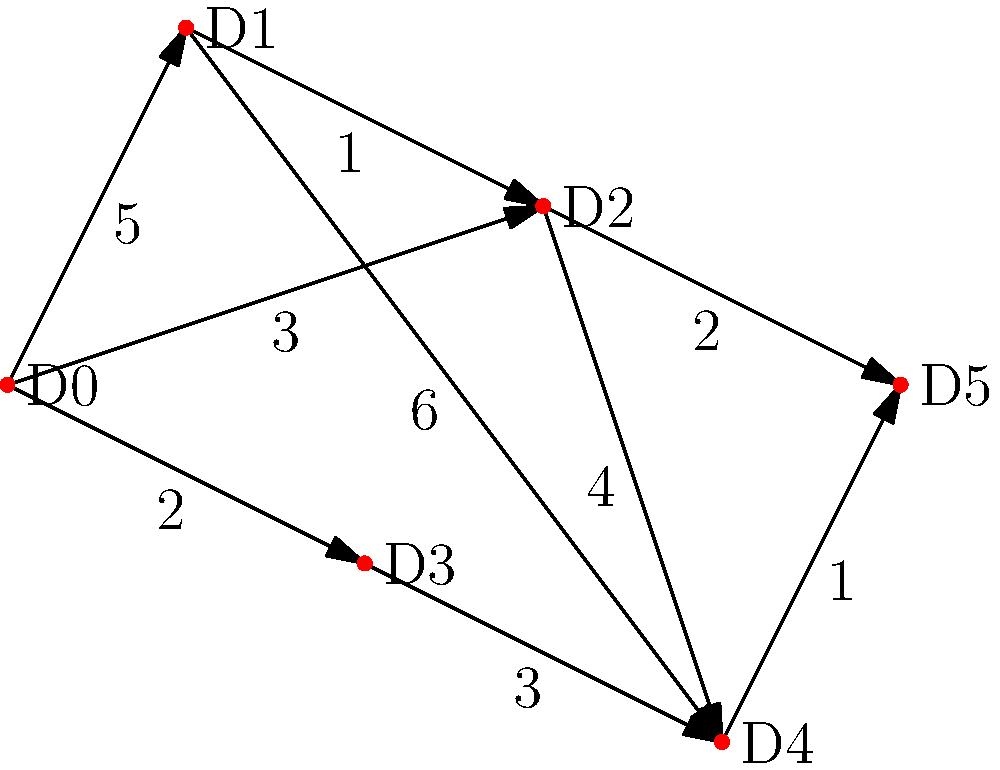In a dark matter detection experiment, you have a network of particle detectors represented by the graph above. Each node (D0 to D5) represents a detector, and the edges represent the data transfer paths between detectors. The numbers on the edges indicate the time (in milliseconds) it takes for data to travel between detectors. What is the shortest time required for data to travel from detector D0 to detector D5? To find the shortest path from D0 to D5, we can use Dijkstra's algorithm:

1. Initialize:
   - Set D0 distance to 0, all others to infinity
   - Set all nodes as unvisited

2. For the current node (starting with D0), consider all unvisited neighbors and calculate their tentative distances:
   - D0 to D1: 5ms
   - D0 to D2: 3ms
   - D0 to D3: 2ms

3. Mark D0 as visited. D3 has the smallest tentative distance (2ms), so make it the current node.

4. From D3:
   - D3 to D4: 2ms + 3ms = 5ms

5. Mark D3 as visited. D2 has the smallest tentative distance (3ms), so make it the current node.

6. From D2:
   - D2 to D1: 3ms + 1ms = 4ms (shorter than current D1 distance, update)
   - D2 to D4: 3ms + 4ms = 7ms (longer than current D4 distance, keep 5ms)
   - D2 to D5: 3ms + 2ms = 5ms

7. Mark D2 as visited. D1 has the smallest tentative distance (4ms), so make it the current node.

8. From D1:
   - D1 to D4: 4ms + 6ms = 10ms (longer than current D4 distance, keep 5ms)

9. Mark D1 as visited. D4 and D5 both have a tentative distance of 5ms. Choose D5 as it's our target.

10. The shortest path is found: D0 → D2 → D5, with a total time of 5ms.
Answer: 5 ms 